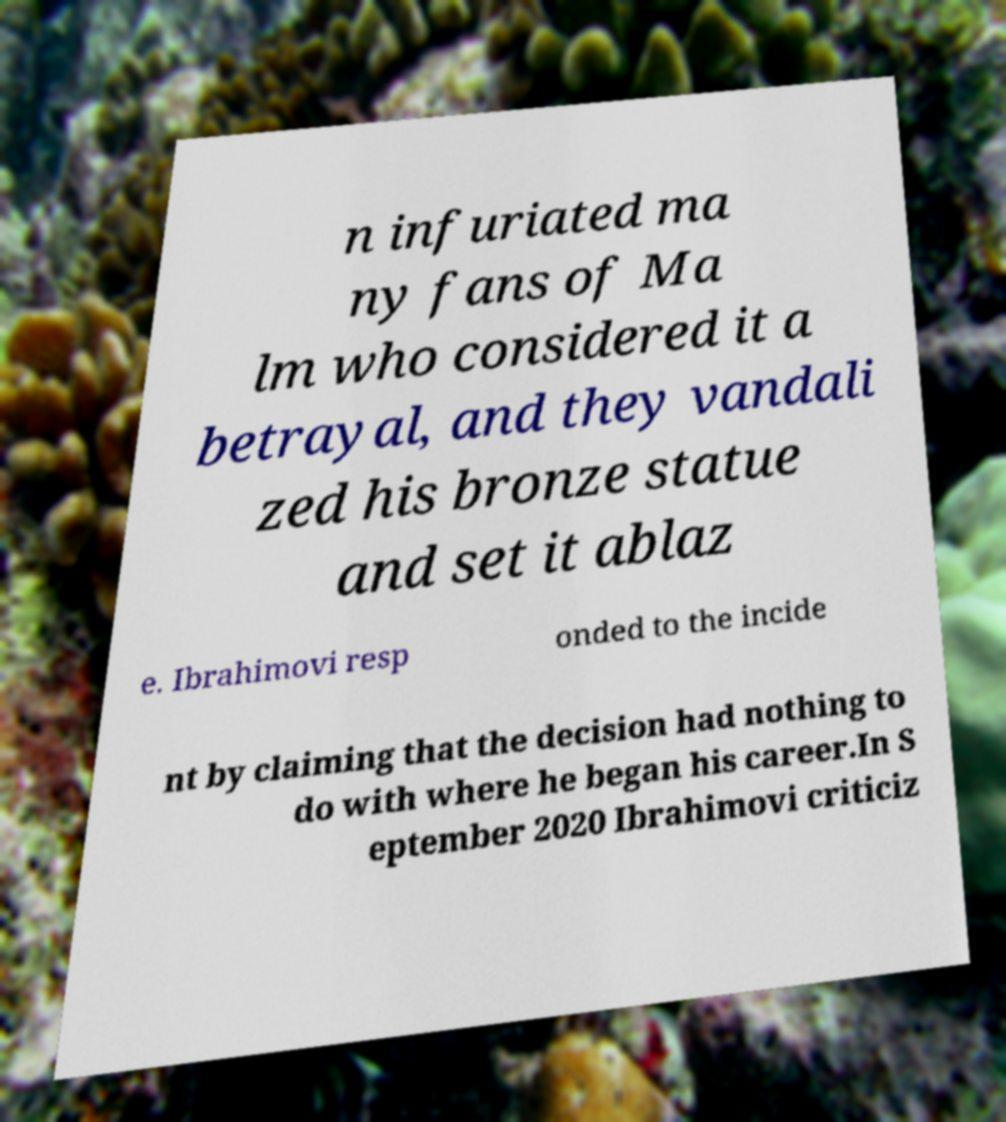Can you accurately transcribe the text from the provided image for me? n infuriated ma ny fans of Ma lm who considered it a betrayal, and they vandali zed his bronze statue and set it ablaz e. Ibrahimovi resp onded to the incide nt by claiming that the decision had nothing to do with where he began his career.In S eptember 2020 Ibrahimovi criticiz 